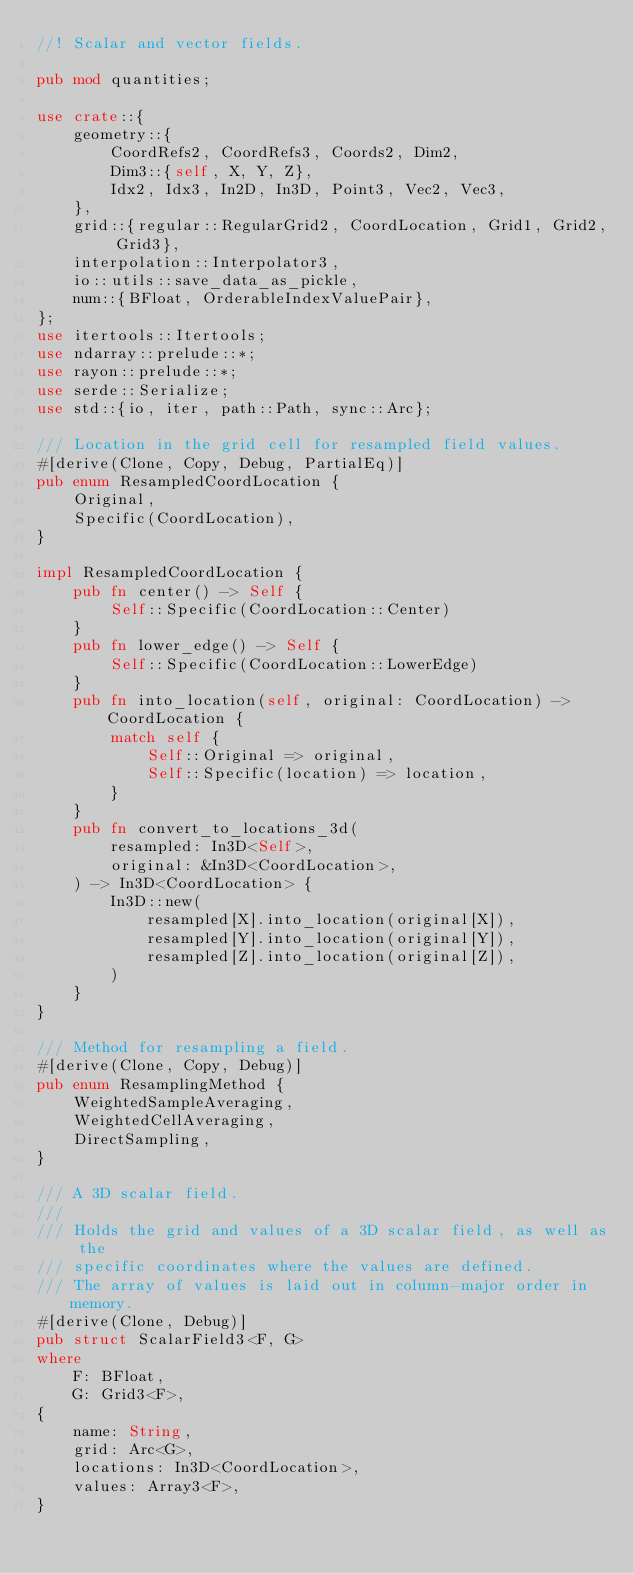<code> <loc_0><loc_0><loc_500><loc_500><_Rust_>//! Scalar and vector fields.

pub mod quantities;

use crate::{
    geometry::{
        CoordRefs2, CoordRefs3, Coords2, Dim2,
        Dim3::{self, X, Y, Z},
        Idx2, Idx3, In2D, In3D, Point3, Vec2, Vec3,
    },
    grid::{regular::RegularGrid2, CoordLocation, Grid1, Grid2, Grid3},
    interpolation::Interpolator3,
    io::utils::save_data_as_pickle,
    num::{BFloat, OrderableIndexValuePair},
};
use itertools::Itertools;
use ndarray::prelude::*;
use rayon::prelude::*;
use serde::Serialize;
use std::{io, iter, path::Path, sync::Arc};

/// Location in the grid cell for resampled field values.
#[derive(Clone, Copy, Debug, PartialEq)]
pub enum ResampledCoordLocation {
    Original,
    Specific(CoordLocation),
}

impl ResampledCoordLocation {
    pub fn center() -> Self {
        Self::Specific(CoordLocation::Center)
    }
    pub fn lower_edge() -> Self {
        Self::Specific(CoordLocation::LowerEdge)
    }
    pub fn into_location(self, original: CoordLocation) -> CoordLocation {
        match self {
            Self::Original => original,
            Self::Specific(location) => location,
        }
    }
    pub fn convert_to_locations_3d(
        resampled: In3D<Self>,
        original: &In3D<CoordLocation>,
    ) -> In3D<CoordLocation> {
        In3D::new(
            resampled[X].into_location(original[X]),
            resampled[Y].into_location(original[Y]),
            resampled[Z].into_location(original[Z]),
        )
    }
}

/// Method for resampling a field.
#[derive(Clone, Copy, Debug)]
pub enum ResamplingMethod {
    WeightedSampleAveraging,
    WeightedCellAveraging,
    DirectSampling,
}

/// A 3D scalar field.
///
/// Holds the grid and values of a 3D scalar field, as well as the
/// specific coordinates where the values are defined.
/// The array of values is laid out in column-major order in memory.
#[derive(Clone, Debug)]
pub struct ScalarField3<F, G>
where
    F: BFloat,
    G: Grid3<F>,
{
    name: String,
    grid: Arc<G>,
    locations: In3D<CoordLocation>,
    values: Array3<F>,
}
</code> 